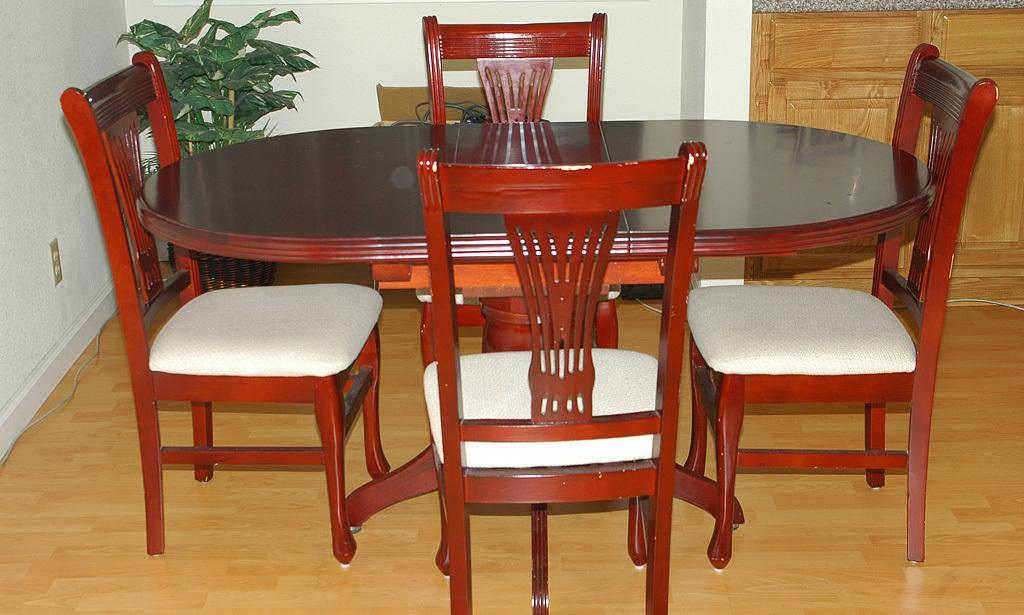What type of furniture is in the center of the image? There is a dining table in the image. What is used for seating around the dining table? Chairs are present around the dining table. What can be seen behind the dining table? There is a plant and other objects behind the table. What is the surrounding environment like in the image? Walls are visible around the table. What type of storage furniture is present in the image? There is a wooden cupboard in the image. What type of peace symbol can be seen on the table in the image? There is no peace symbol present on the table in the image. 